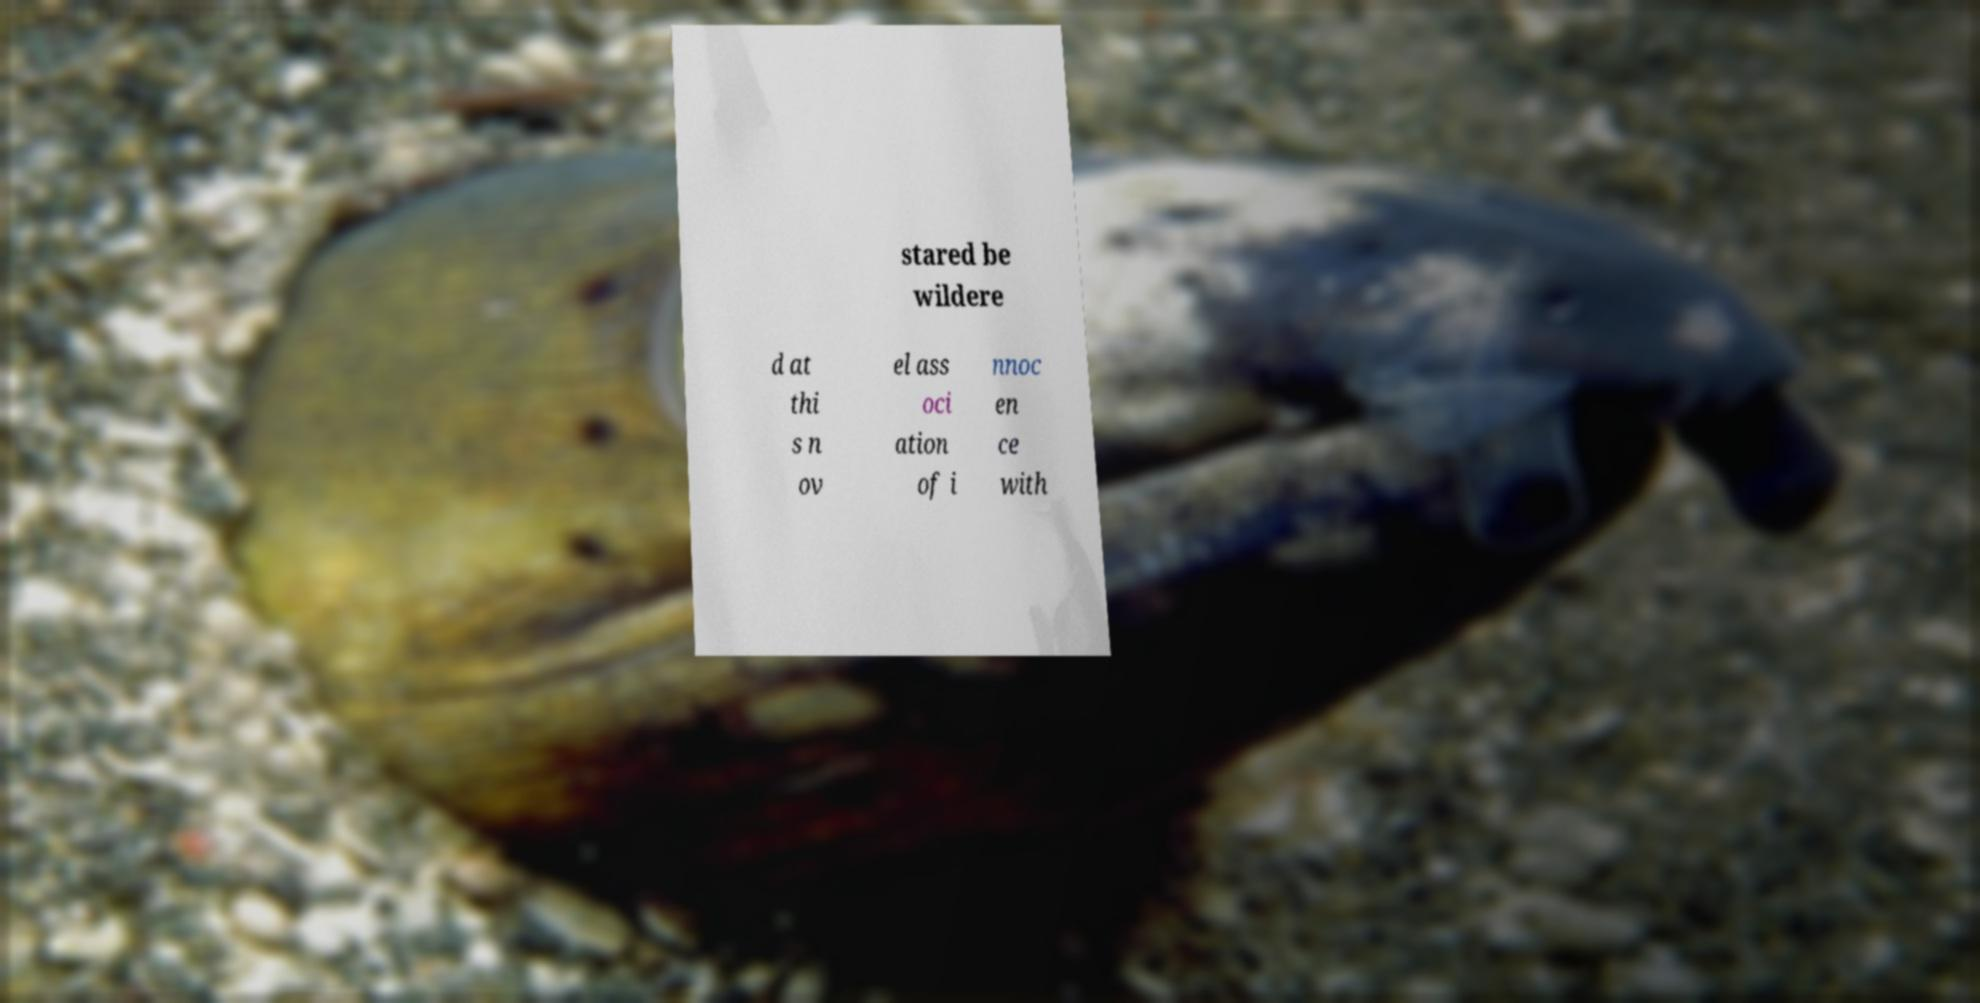Please read and relay the text visible in this image. What does it say? stared be wildere d at thi s n ov el ass oci ation of i nnoc en ce with 